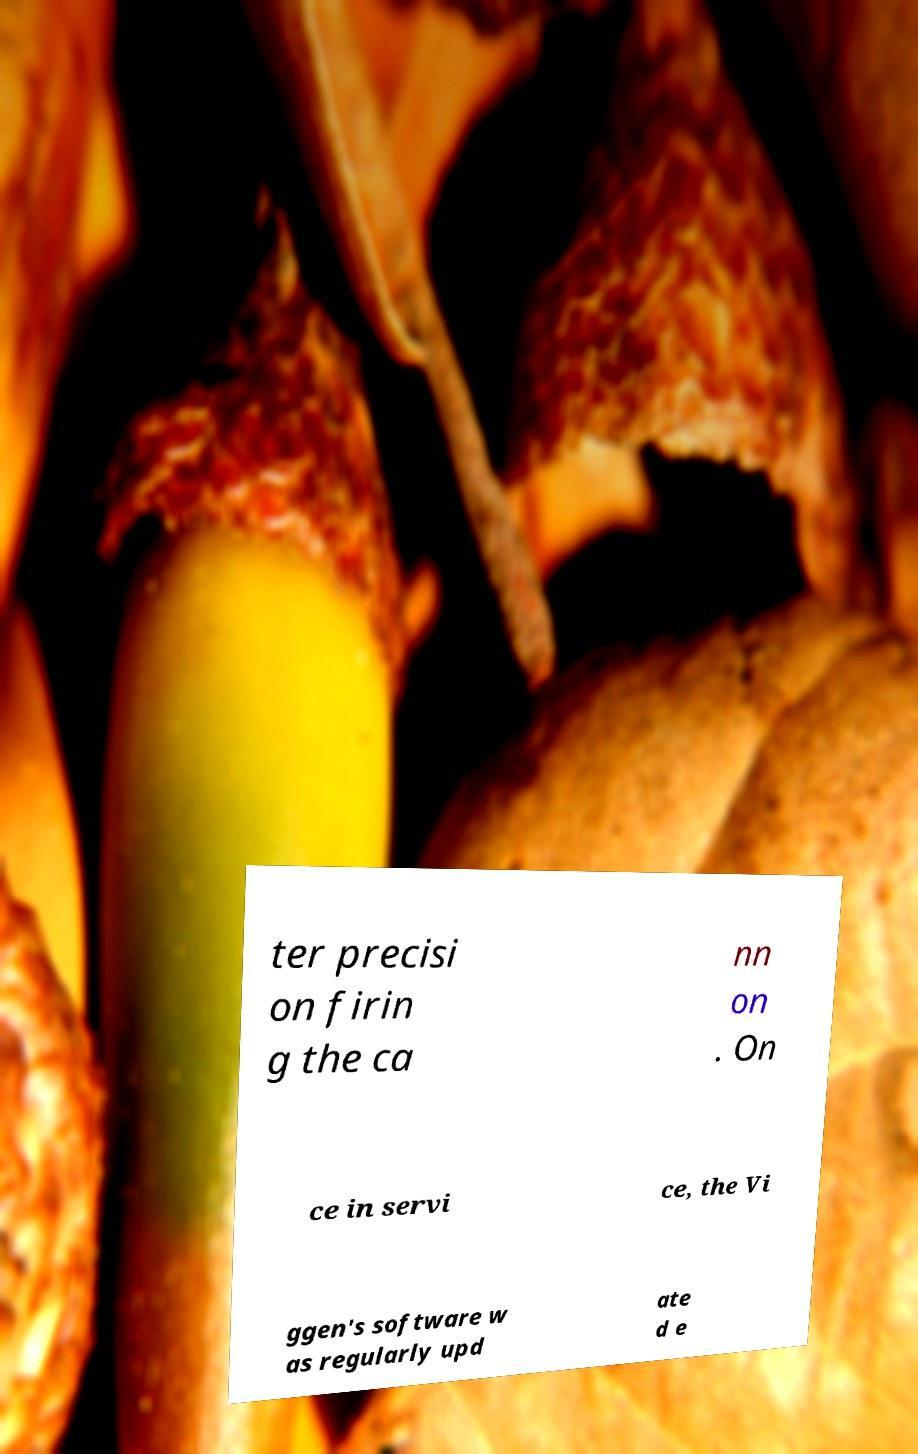For documentation purposes, I need the text within this image transcribed. Could you provide that? ter precisi on firin g the ca nn on . On ce in servi ce, the Vi ggen's software w as regularly upd ate d e 